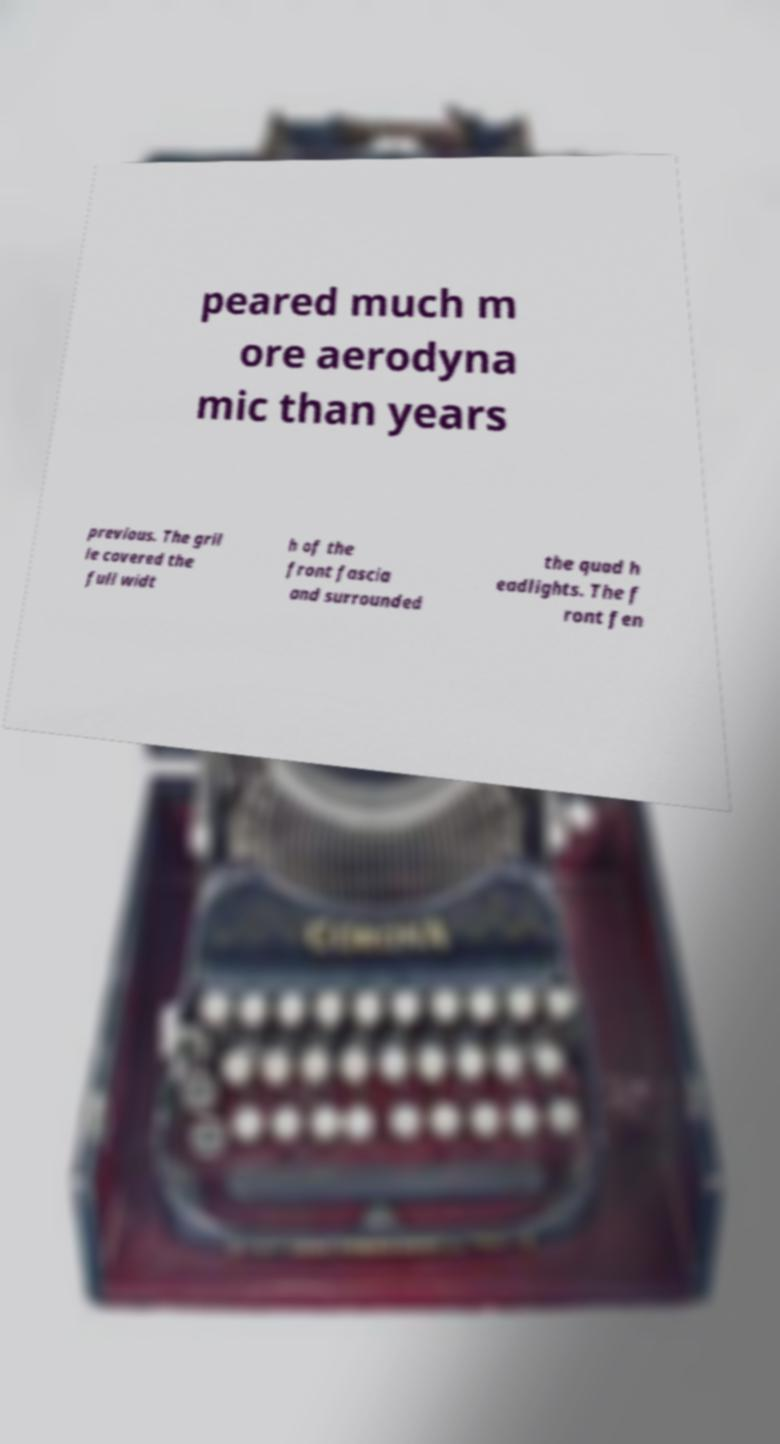There's text embedded in this image that I need extracted. Can you transcribe it verbatim? peared much m ore aerodyna mic than years previous. The gril le covered the full widt h of the front fascia and surrounded the quad h eadlights. The f ront fen 